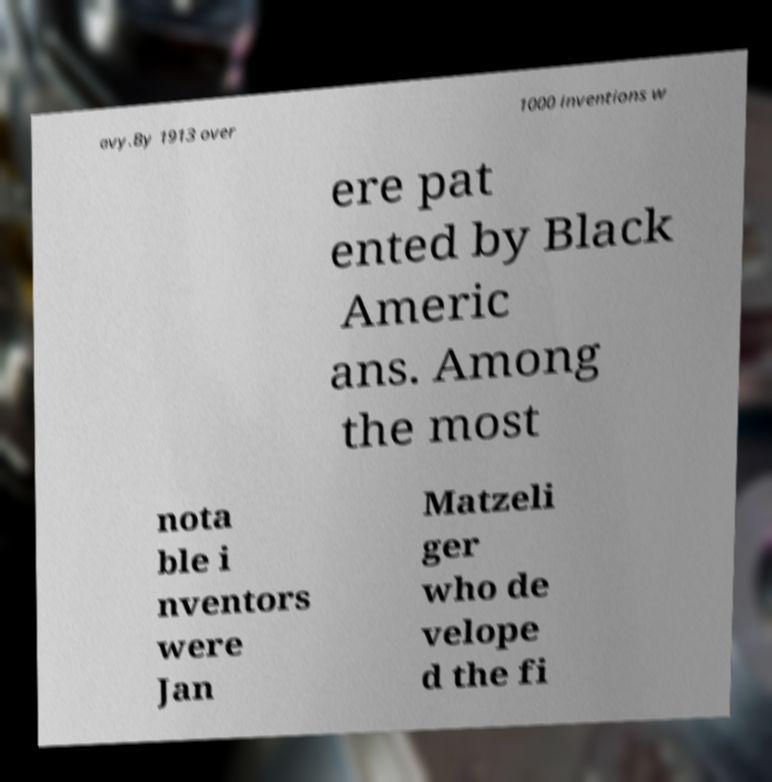Can you accurately transcribe the text from the provided image for me? avy.By 1913 over 1000 inventions w ere pat ented by Black Americ ans. Among the most nota ble i nventors were Jan Matzeli ger who de velope d the fi 